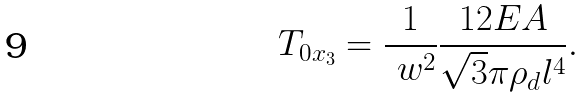Convert formula to latex. <formula><loc_0><loc_0><loc_500><loc_500>T _ { 0 x _ { 3 } } = \frac { 1 } { \ w ^ { 2 } } \frac { 1 2 E A } { \sqrt { 3 } \pi \rho _ { d } l ^ { 4 } } .</formula> 